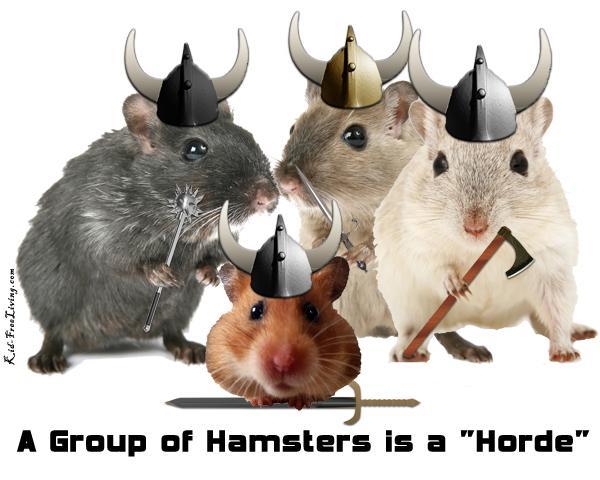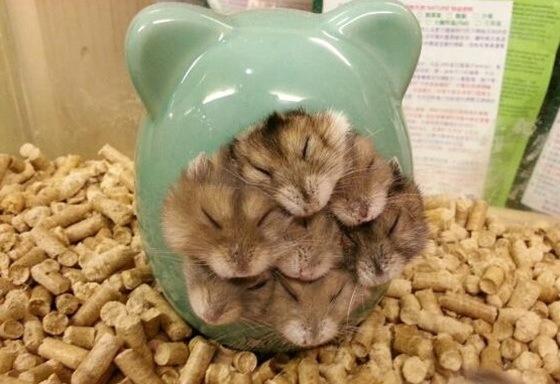The first image is the image on the left, the second image is the image on the right. Analyze the images presented: Is the assertion "The right image features exactly four hamsters." valid? Answer yes or no. No. 